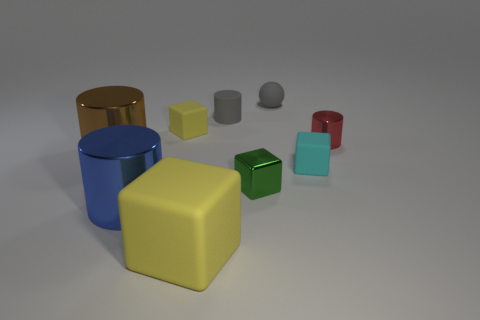Subtract 1 cylinders. How many cylinders are left? 3 Subtract all cylinders. How many objects are left? 5 Add 4 gray rubber things. How many gray rubber things are left? 6 Add 5 small matte spheres. How many small matte spheres exist? 6 Subtract 0 gray cubes. How many objects are left? 9 Subtract all green metal blocks. Subtract all brown metal balls. How many objects are left? 8 